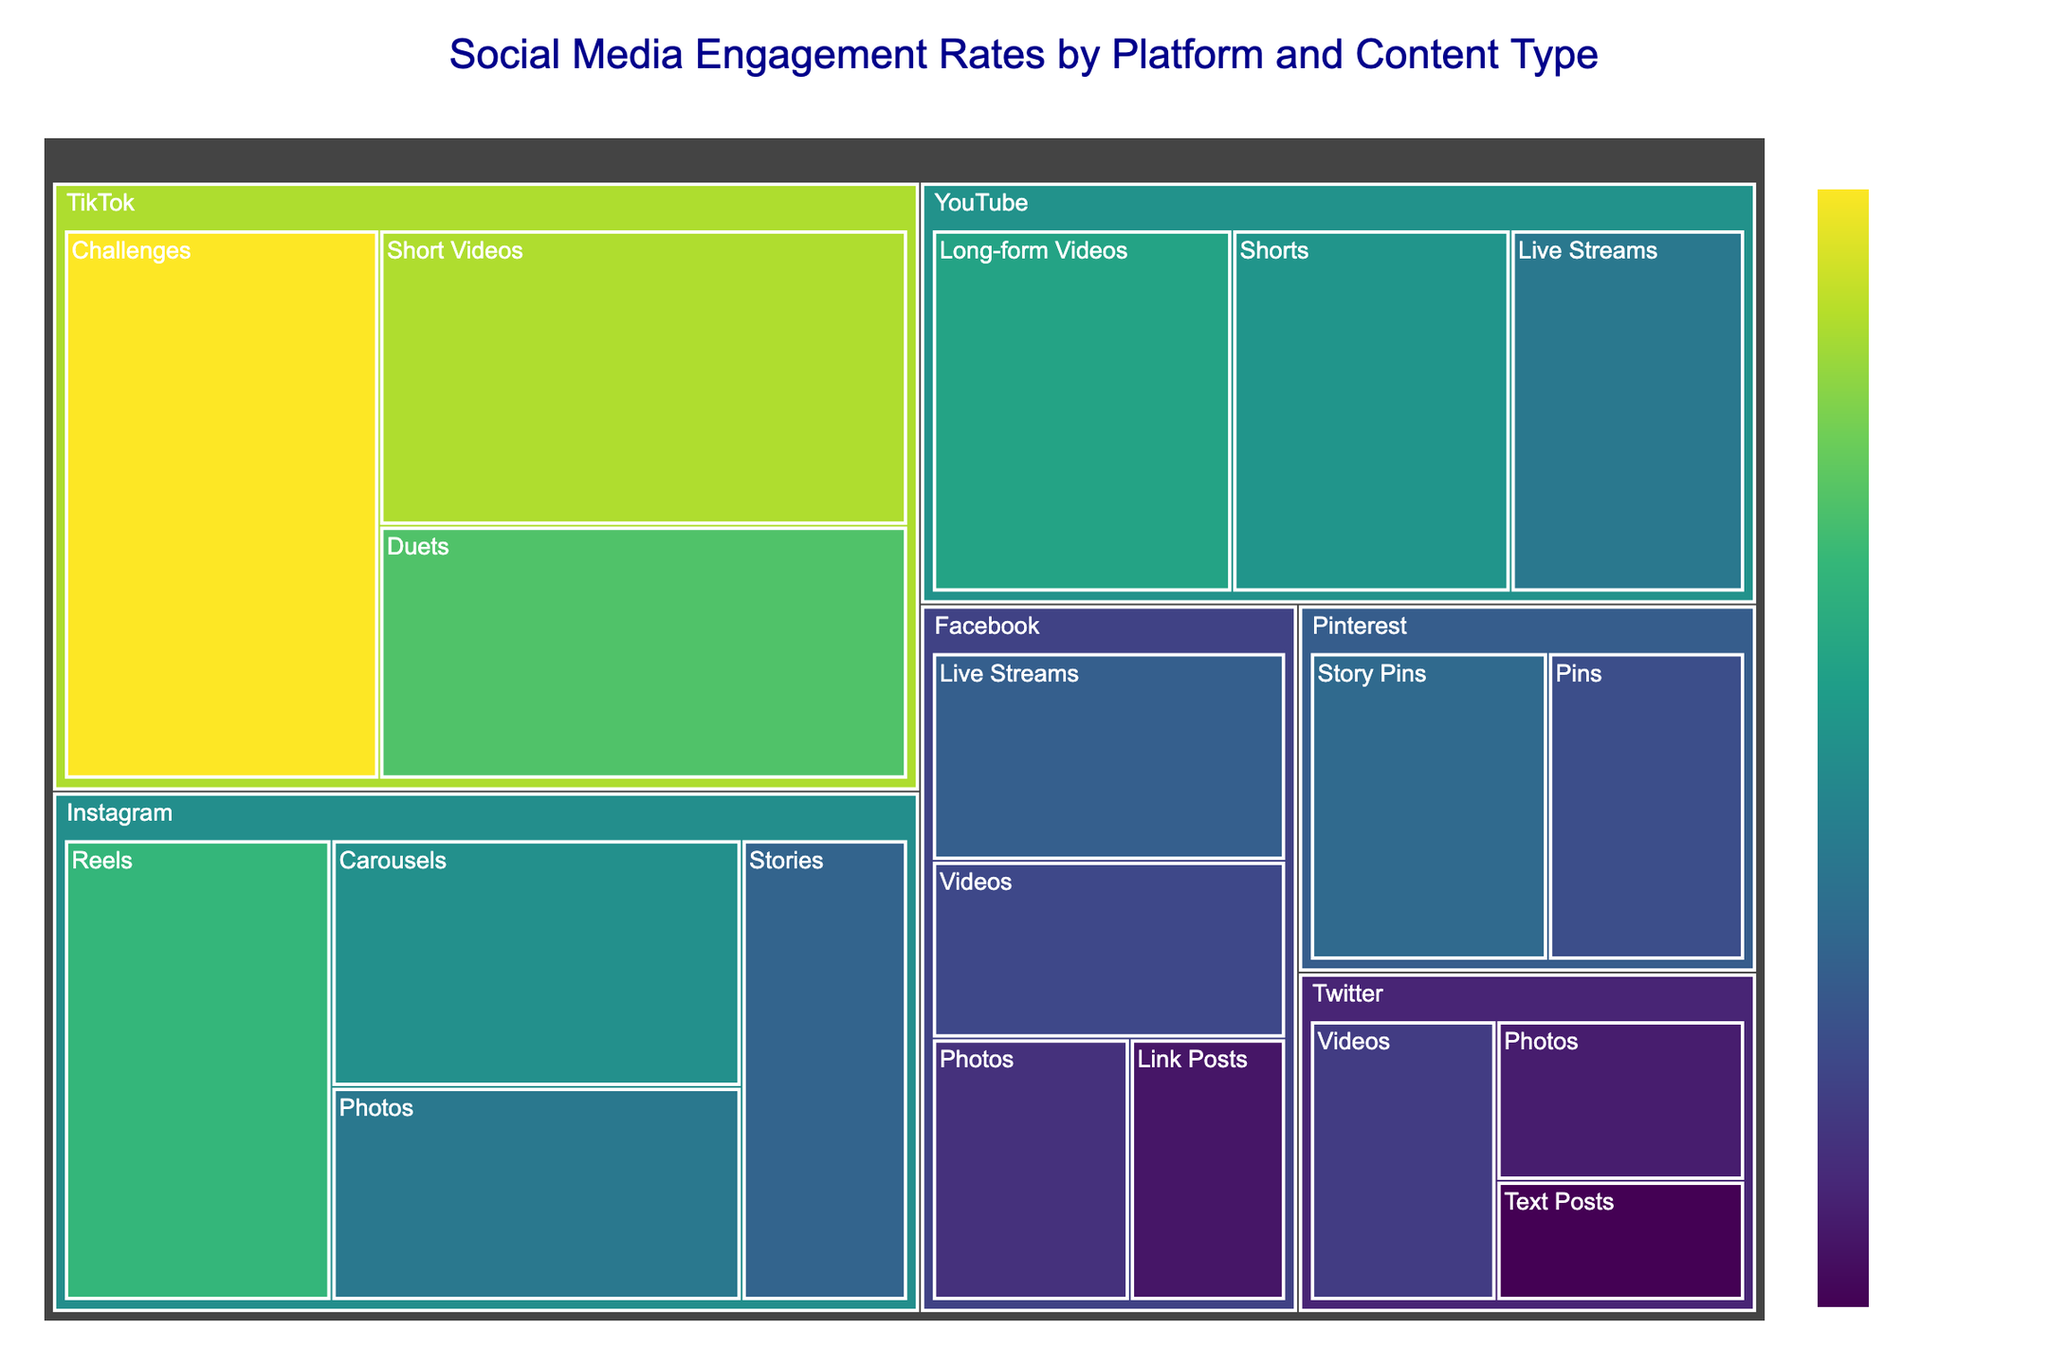How many platforms are displayed in the treemap? Count the unique platforms listed on the treemap: Instagram, Facebook, YouTube, TikTok, Twitter, Pinterest.
Answer: 6 Which platform has the highest engagement rate for any content type, and what is that rate? Identify the highest engagement rate value, which is 6.2%, and locate which platform it belongs to; it's on TikTok for Challenges.
Answer: TikTok, 6.2% What is the difference in engagement rate between Instagram Reels and Facebook Live Streams? Find the engagement rates for Instagram Reels (4.5%) and Facebook Live Streams (2.7%). Subtract the smaller rate from the larger one: 4.5% - 2.7% = 1.8%.
Answer: 1.8% Which content type on Pinterest has the highest engagement rate? Compare engagement rates of content types under Pinterest: Pins (2.4%) and Story Pins (2.9%). The highest rate is 2.9% for Story Pins.
Answer: Story Pins What is the overall average engagement rate of YouTube content types? Sum the engagement rates of YouTube content types: (4.1% for Long-form Videos + 3.8% for Shorts + 3.2% for Live Streams) = 11.1%. Divide by the number of content types, which is 3: 11.1% / 3 = 3.7%.
Answer: 3.7% How does the engagement rate of Instagram Carousels compare to Twitter Videos? Find the engagement rates of Instagram Carousels (3.7%) and Twitter Videos (2.1%). Compare the two: Instagram Carousels (3.7%) is greater than Twitter Videos (2.1%).
Answer: Instagram Carousels > Twitter Videos What is the engagement rate range (difference between highest and lowest rates) within TikTok? Identify the highest (Challenges, 6.2%) and lowest (Duets, 4.8%) engagement rates for TikTok. Subtract the lowest from the highest: 6.2% - 4.8% = 1.4%.
Answer: 1.4% Which platform has the lowest average engagement rate across all its content types? Calculate each platform's average engagement rate and identify the lowest: 
1. Instagram: (3.2% + 2.8% + 4.5% + 3.7%) / 4 = 3.55%
2. Facebook: (1.9% + 2.3% + 2.7% + 1.5%) / 4 = 2.1%
3. YouTube: (4.1% + 3.8% + 3.2%) / 3 = 3.7%
4. TikTok: (5.6% + 6.2% + 4.8%) / 3 = 5.53%
5. Twitter: (1.2% + 1.6% + 2.1%) / 3 = 1.63%
6. Pinterest: (2.4% + 2.9%) / 2 = 2.65%
The lowest average is for Twitter at 1.63%.
Answer: Twitter What content type across all platforms has the highest engagement rate, and which platform does it belong to? Identify the highest engagement rate value in the dataset, which is 6.2%, and locate the corresponding content type and platform; it's Challenges on TikTok.
Answer: Challenges, TikTok How many content types are listed under Facebook? Count the distinct content types listed under Facebook: Photos, Videos, Live Streams, Link Posts.
Answer: 4 